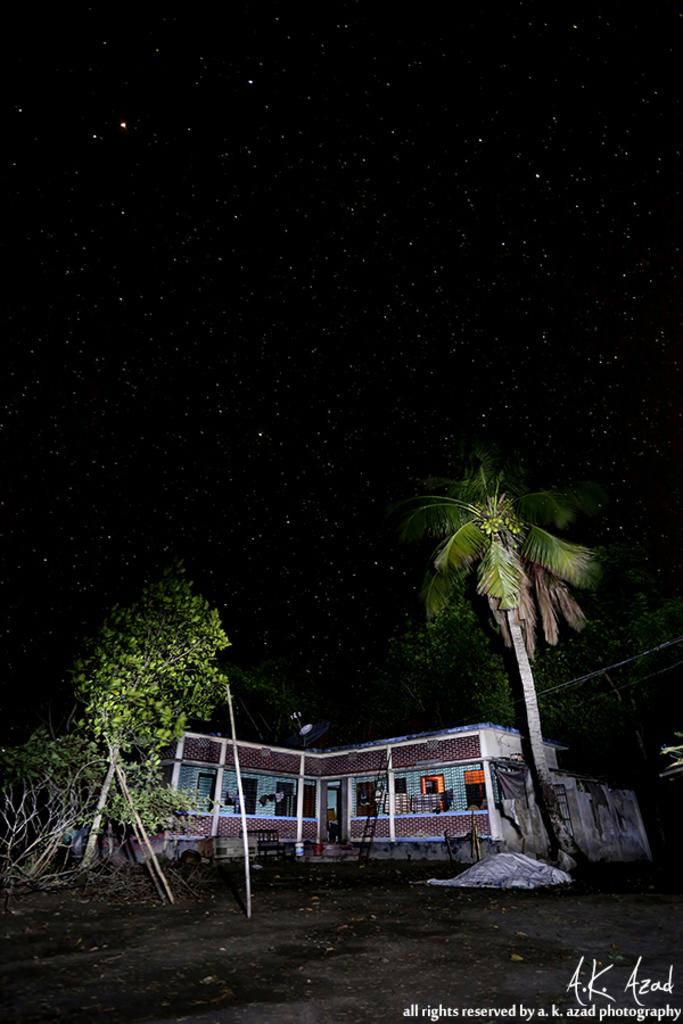What type of vegetation is at the bottom of the image? There are trees at the bottom of the image. What structure is visible behind the trees? There is a building behind the trees. What type of sack can be seen hanging from the trees in the image? There is no sack present in the image; it only features trees and a building. What kind of teeth can be seen on the building in the image? There are no teeth visible in the image, as buildings do not have teeth. 